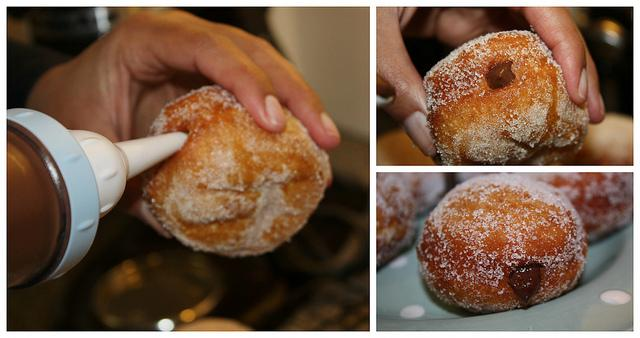What does the container hold? Please explain your reasoning. jelly. The person is squeezing the fruit filling for these kind of donuts into the holes 